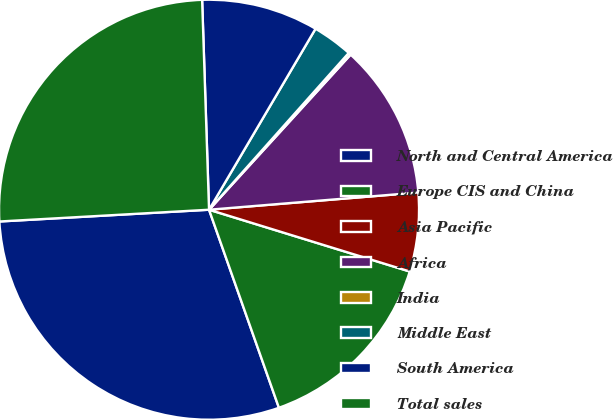Convert chart to OTSL. <chart><loc_0><loc_0><loc_500><loc_500><pie_chart><fcel>North and Central America<fcel>Europe CIS and China<fcel>Asia Pacific<fcel>Africa<fcel>India<fcel>Middle East<fcel>South America<fcel>Total sales<nl><fcel>29.51%<fcel>14.85%<fcel>6.06%<fcel>11.92%<fcel>0.19%<fcel>3.12%<fcel>8.99%<fcel>25.37%<nl></chart> 